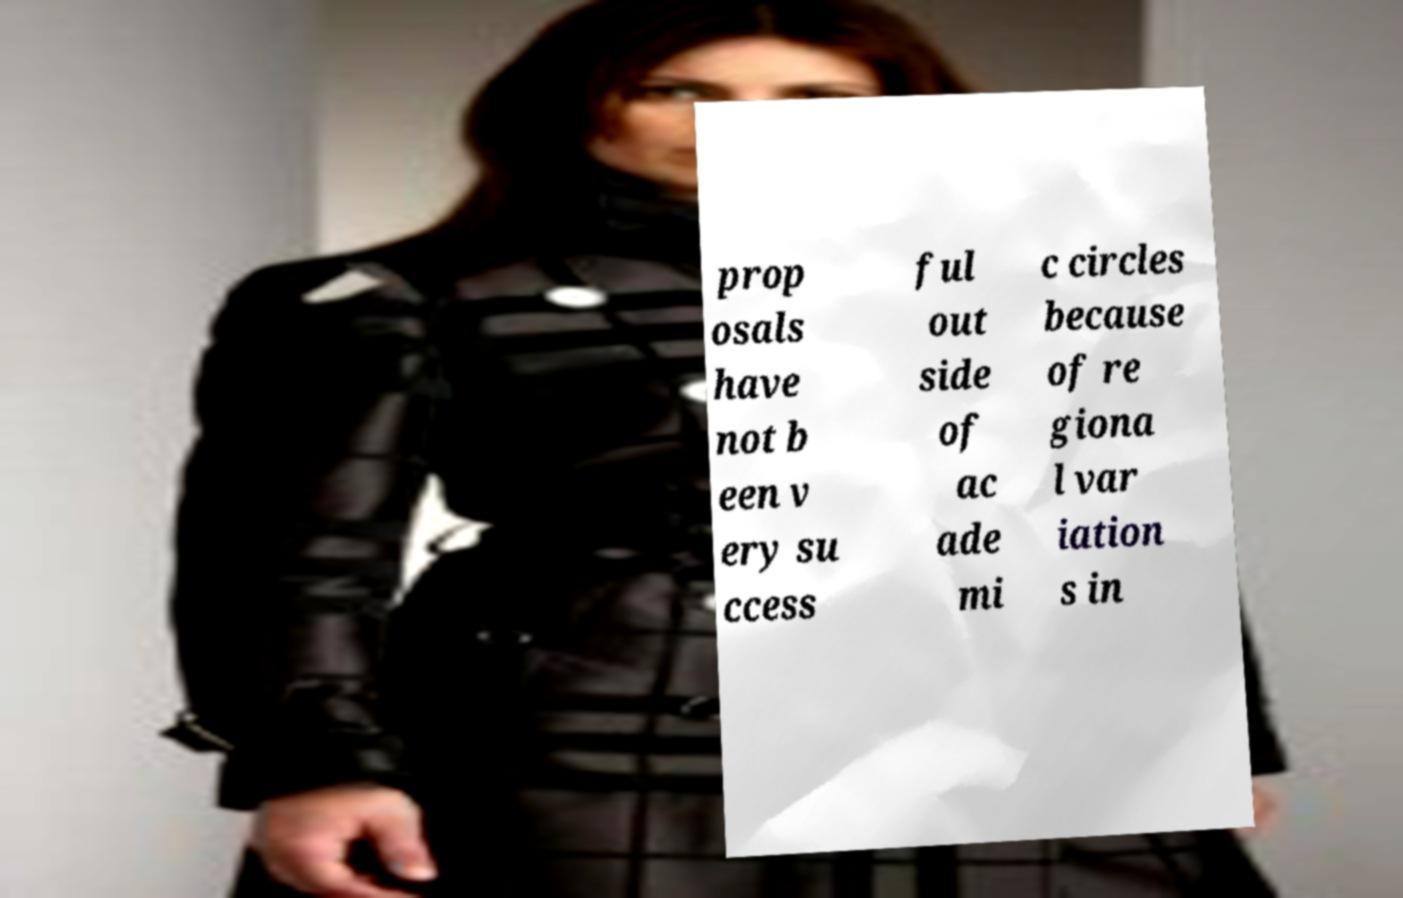Can you accurately transcribe the text from the provided image for me? prop osals have not b een v ery su ccess ful out side of ac ade mi c circles because of re giona l var iation s in 